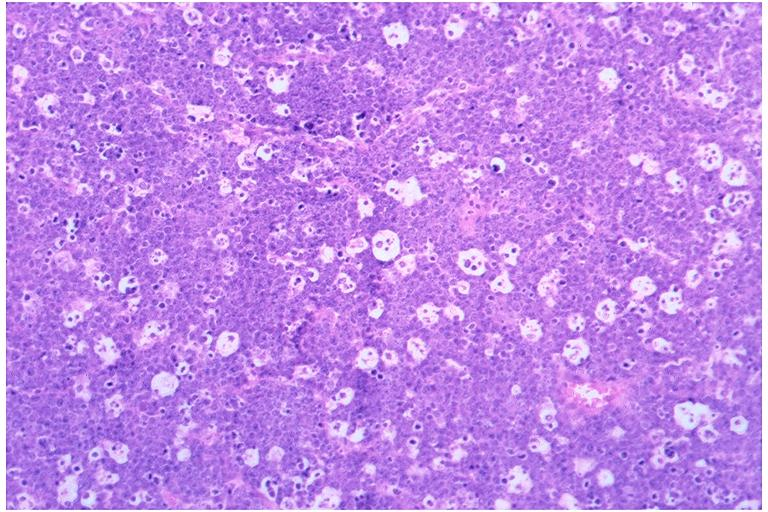what is present?
Answer the question using a single word or phrase. Oral 